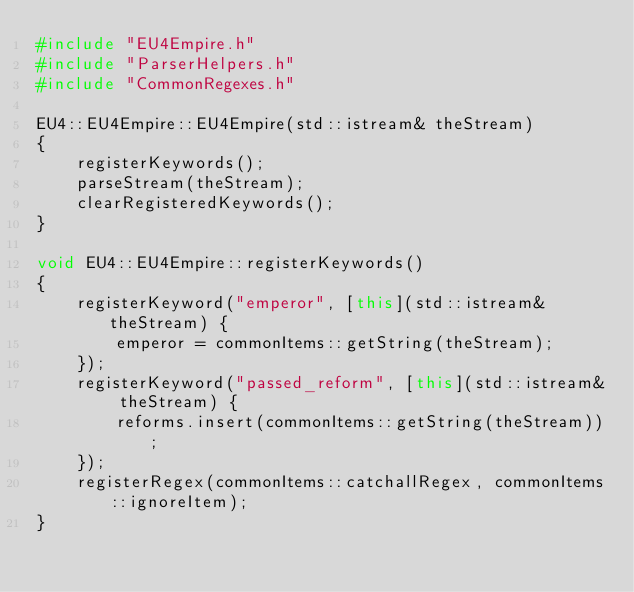Convert code to text. <code><loc_0><loc_0><loc_500><loc_500><_C++_>#include "EU4Empire.h"
#include "ParserHelpers.h"
#include "CommonRegexes.h"

EU4::EU4Empire::EU4Empire(std::istream& theStream)
{
	registerKeywords();
	parseStream(theStream);
	clearRegisteredKeywords();
}

void EU4::EU4Empire::registerKeywords()
{
	registerKeyword("emperor", [this](std::istream& theStream) {
		emperor = commonItems::getString(theStream);
	});
	registerKeyword("passed_reform", [this](std::istream& theStream) {
		reforms.insert(commonItems::getString(theStream));
	});
	registerRegex(commonItems::catchallRegex, commonItems::ignoreItem);
}
</code> 